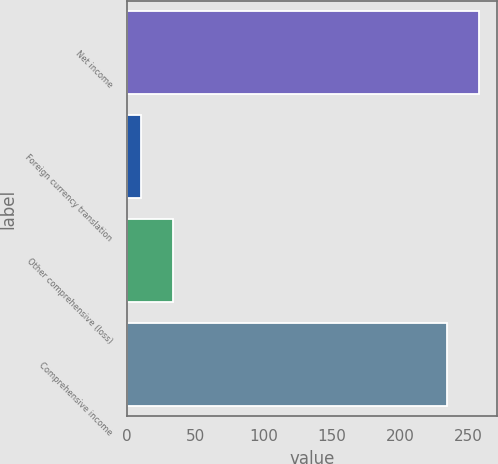Convert chart. <chart><loc_0><loc_0><loc_500><loc_500><bar_chart><fcel>Net income<fcel>Foreign currency translation<fcel>Other comprehensive (loss)<fcel>Comprehensive income<nl><fcel>258.06<fcel>10.3<fcel>33.76<fcel>234.6<nl></chart> 